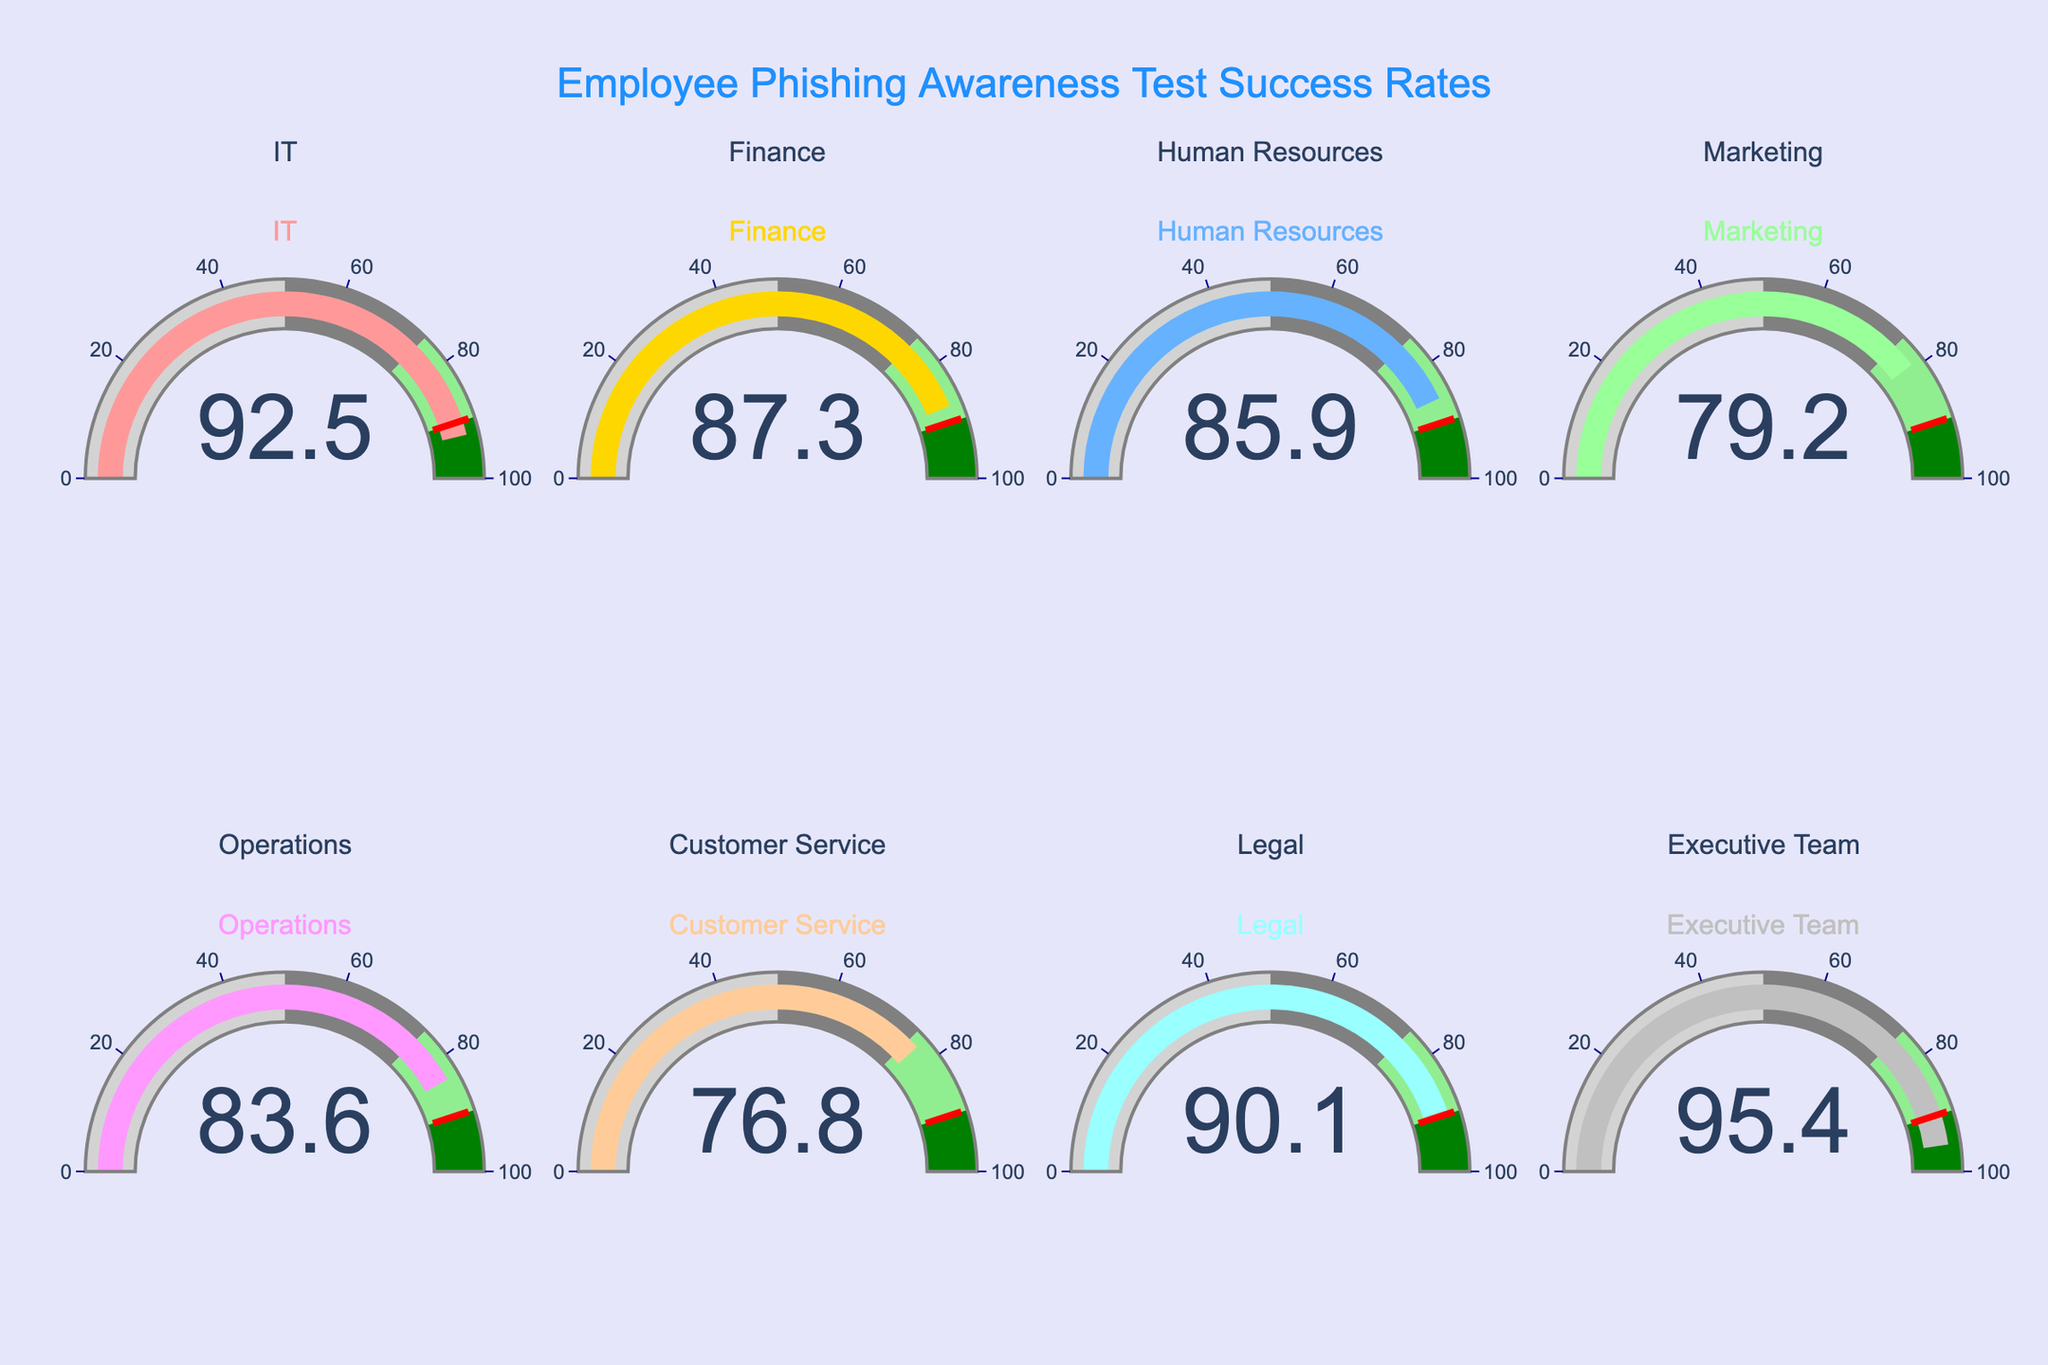What is the success rate of the IT department? Look at the gauge labeled 'IT' and read the number inside it.
Answer: 92.5% Which department has the highest success rate? Examine all the gauges and find the one with the highest value displayed. The 'Executive Team' has the highest value at 95.4%.
Answer: Executive Team Which department has the lowest success rate? Look at all the gauges and identify the one with the lowest number displayed. The 'Customer Service' department shows the lowest value at 76.8%.
Answer: Customer Service How many departments have a success rate above 90%? Count the number of gauges with values greater than 90%. Three departments—IT, Legal, and Executive Team—have success rates above 90%.
Answer: 3 What is the average success rate of the departments? Add all the success rates together and divide by the number of departments. (92.5 + 87.3 + 85.9 + 79.2 + 83.6 + 76.8 + 90.1 + 95.4) / 8 = 85.1
Answer: 85.1% What is the difference in success rates between IT and Finance departments? Subtract the success rate of Finance from that of IT. 92.5 - 87.3 = 5.2
Answer: 5.2% Which departments have success rates between 80% and 90%? Look at the gauges and identify the ones with values between 80 and 90. Finance, Human Resources, Operations, and Marketing fall within this range.
Answer: Finance, Human Resources, Operations, Marketing How many departments fall below the threshold success rate of 90%? Count the number of gauges with values less than 90%. Five departments—Finance, Human Resources, Marketing, Operations, and Customer Service—have success rates below 90%.
Answer: 5 